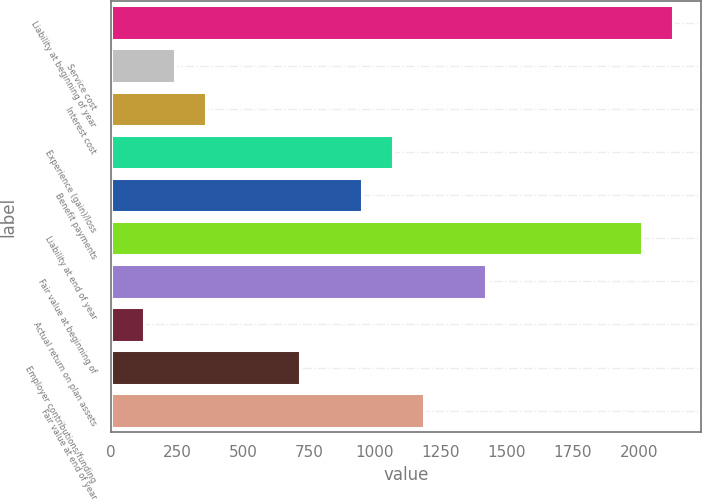Convert chart. <chart><loc_0><loc_0><loc_500><loc_500><bar_chart><fcel>Liability at beginning of year<fcel>Service cost<fcel>Interest cost<fcel>Experience (gain)/loss<fcel>Benefit payments<fcel>Liability at end of year<fcel>Fair value at beginning of<fcel>Actual return on plan assets<fcel>Employer contributions/funding<fcel>Fair value at end of year<nl><fcel>2130.2<fcel>243.8<fcel>361.7<fcel>1069.1<fcel>951.2<fcel>2012.3<fcel>1422.8<fcel>125.9<fcel>715.4<fcel>1187<nl></chart> 